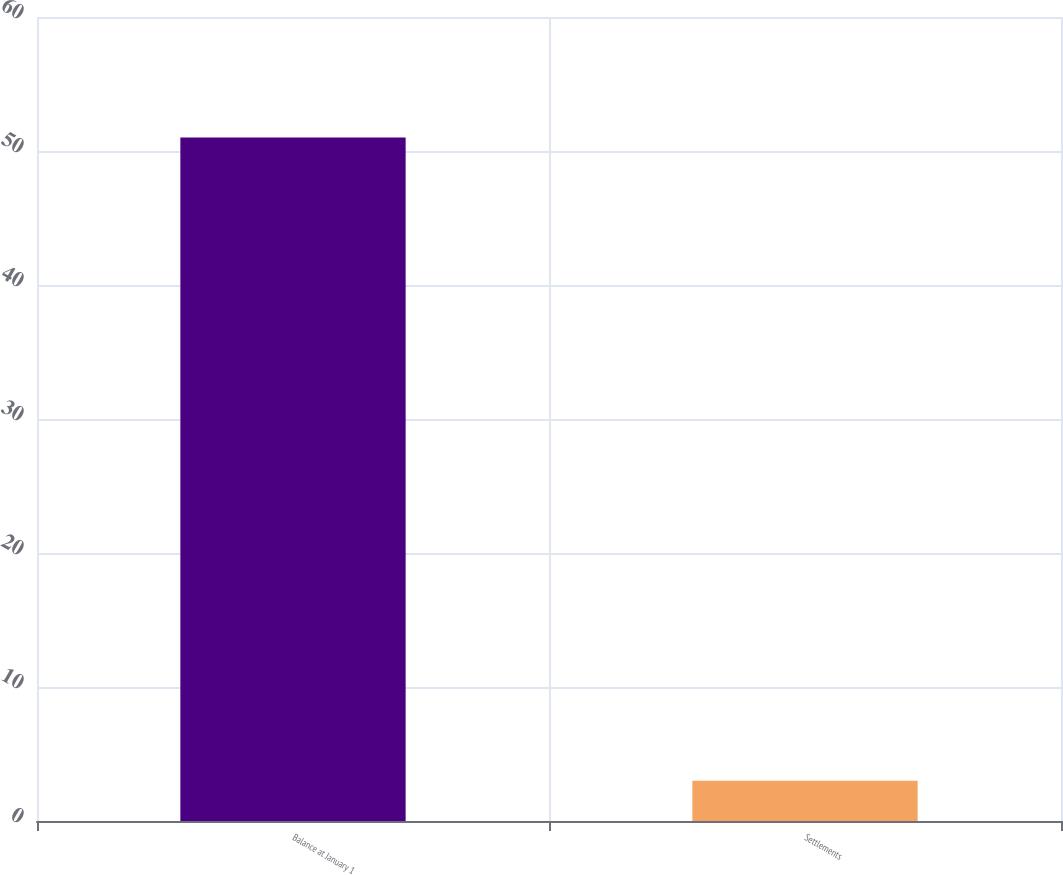Convert chart to OTSL. <chart><loc_0><loc_0><loc_500><loc_500><bar_chart><fcel>Balance at January 1<fcel>Settlements<nl><fcel>51<fcel>3<nl></chart> 